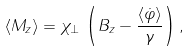Convert formula to latex. <formula><loc_0><loc_0><loc_500><loc_500>\langle M _ { z } \rangle = \chi _ { \bot } \, \left ( B _ { z } - \frac { \langle \dot { \varphi } \rangle } \gamma \right ) ,</formula> 